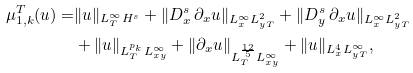Convert formula to latex. <formula><loc_0><loc_0><loc_500><loc_500>\mu _ { 1 , k } ^ { T } ( u ) = & \| u \| _ { L _ { T } ^ { \infty } H ^ { s } } + \| D _ { x } ^ { s } \, \partial _ { x } u \| _ { L _ { x } ^ { \infty } L _ { y T } ^ { 2 } } + \| D _ { y } ^ { s } \, \partial _ { x } u \| _ { L _ { x } ^ { \infty } L _ { y T } ^ { 2 } } \\ & + \| u \| _ { L _ { T } ^ { p _ { k } } L _ { x y } ^ { \infty } } + \| \partial _ { x } u \| _ { L _ { T } ^ { \frac { 1 2 } { 5 } } L _ { x y } ^ { \infty } } + \| u \| _ { L _ { x } ^ { 4 } L _ { y T } ^ { \infty } } ,</formula> 